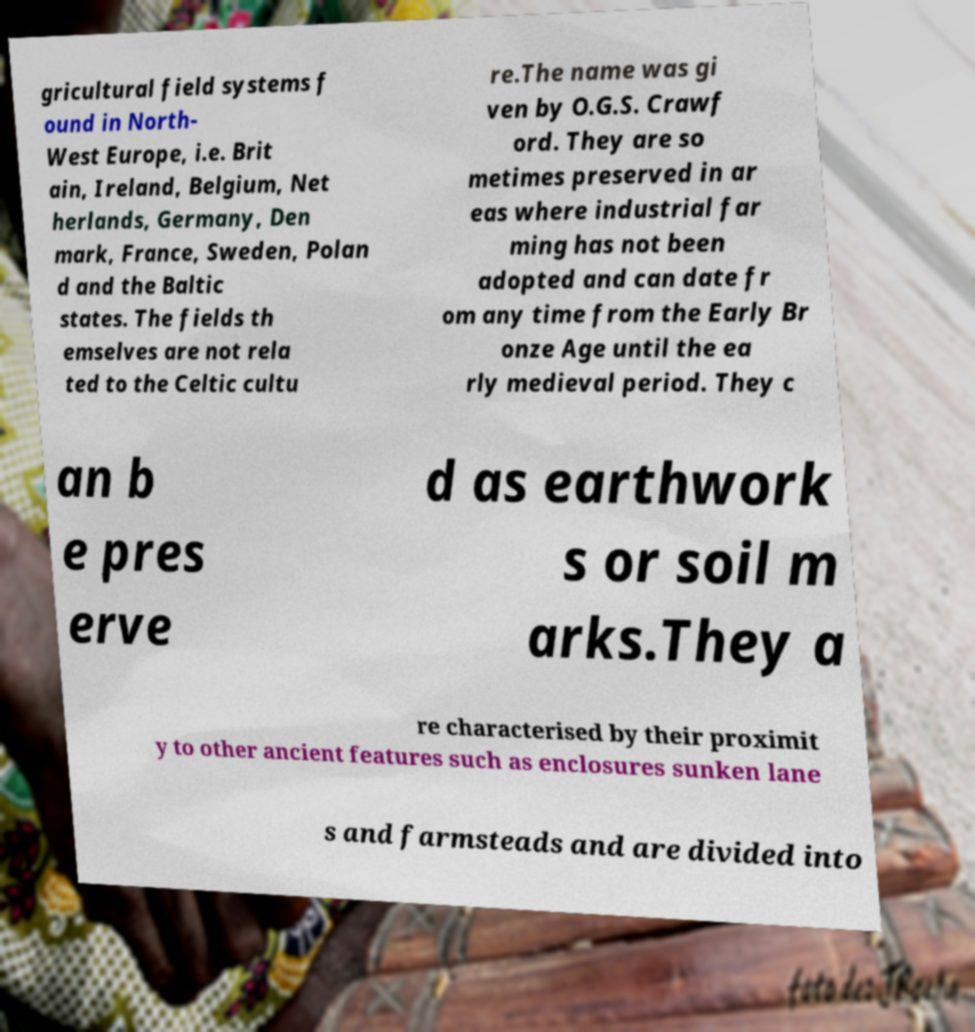Could you extract and type out the text from this image? gricultural field systems f ound in North- West Europe, i.e. Brit ain, Ireland, Belgium, Net herlands, Germany, Den mark, France, Sweden, Polan d and the Baltic states. The fields th emselves are not rela ted to the Celtic cultu re.The name was gi ven by O.G.S. Crawf ord. They are so metimes preserved in ar eas where industrial far ming has not been adopted and can date fr om any time from the Early Br onze Age until the ea rly medieval period. They c an b e pres erve d as earthwork s or soil m arks.They a re characterised by their proximit y to other ancient features such as enclosures sunken lane s and farmsteads and are divided into 